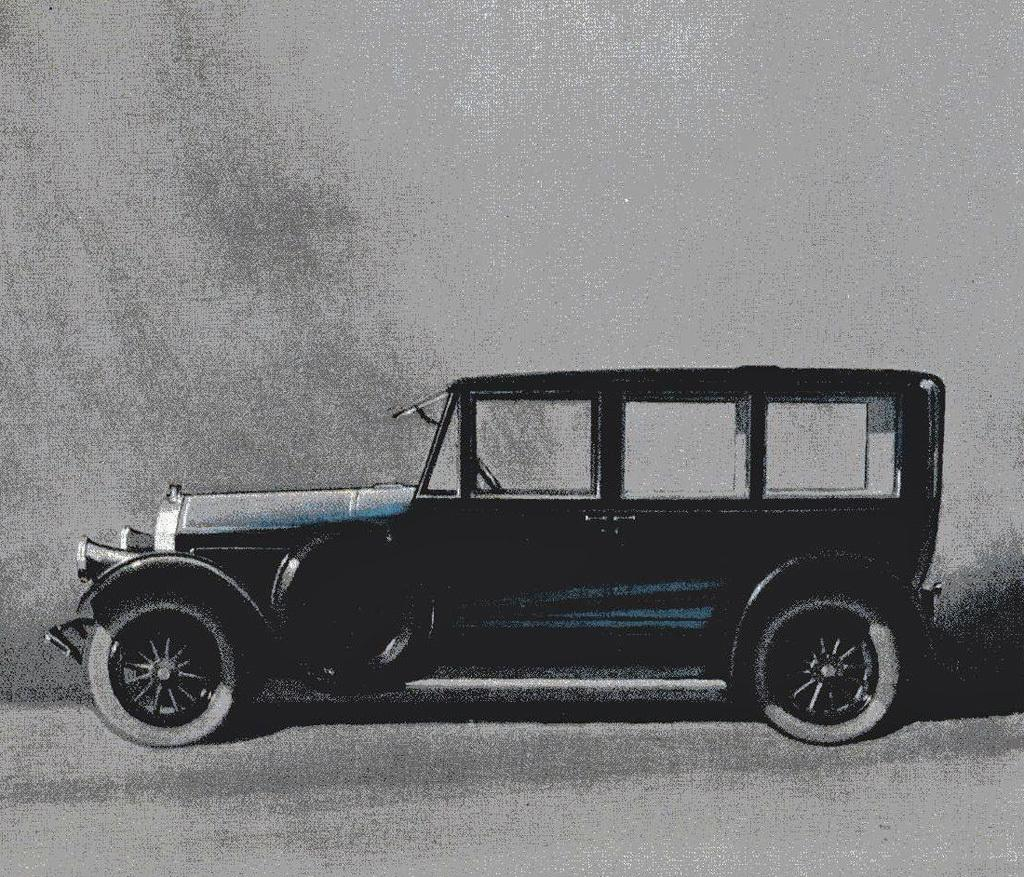What type of artwork is depicted in the image? The image is a drawing. What is the main subject of the drawing? There is a car in the center of the drawing. What colors are used for the top and bottom of the drawing? The top and bottom of the drawing are grey in color. Can you tell me how many umbrellas are open in the drawing? There are no umbrellas present in the drawing; it features a car and is primarily grey in color. What type of suggestion is being made by the car in the drawing? The drawing is not making any suggestions, as it is a static image of a car. 